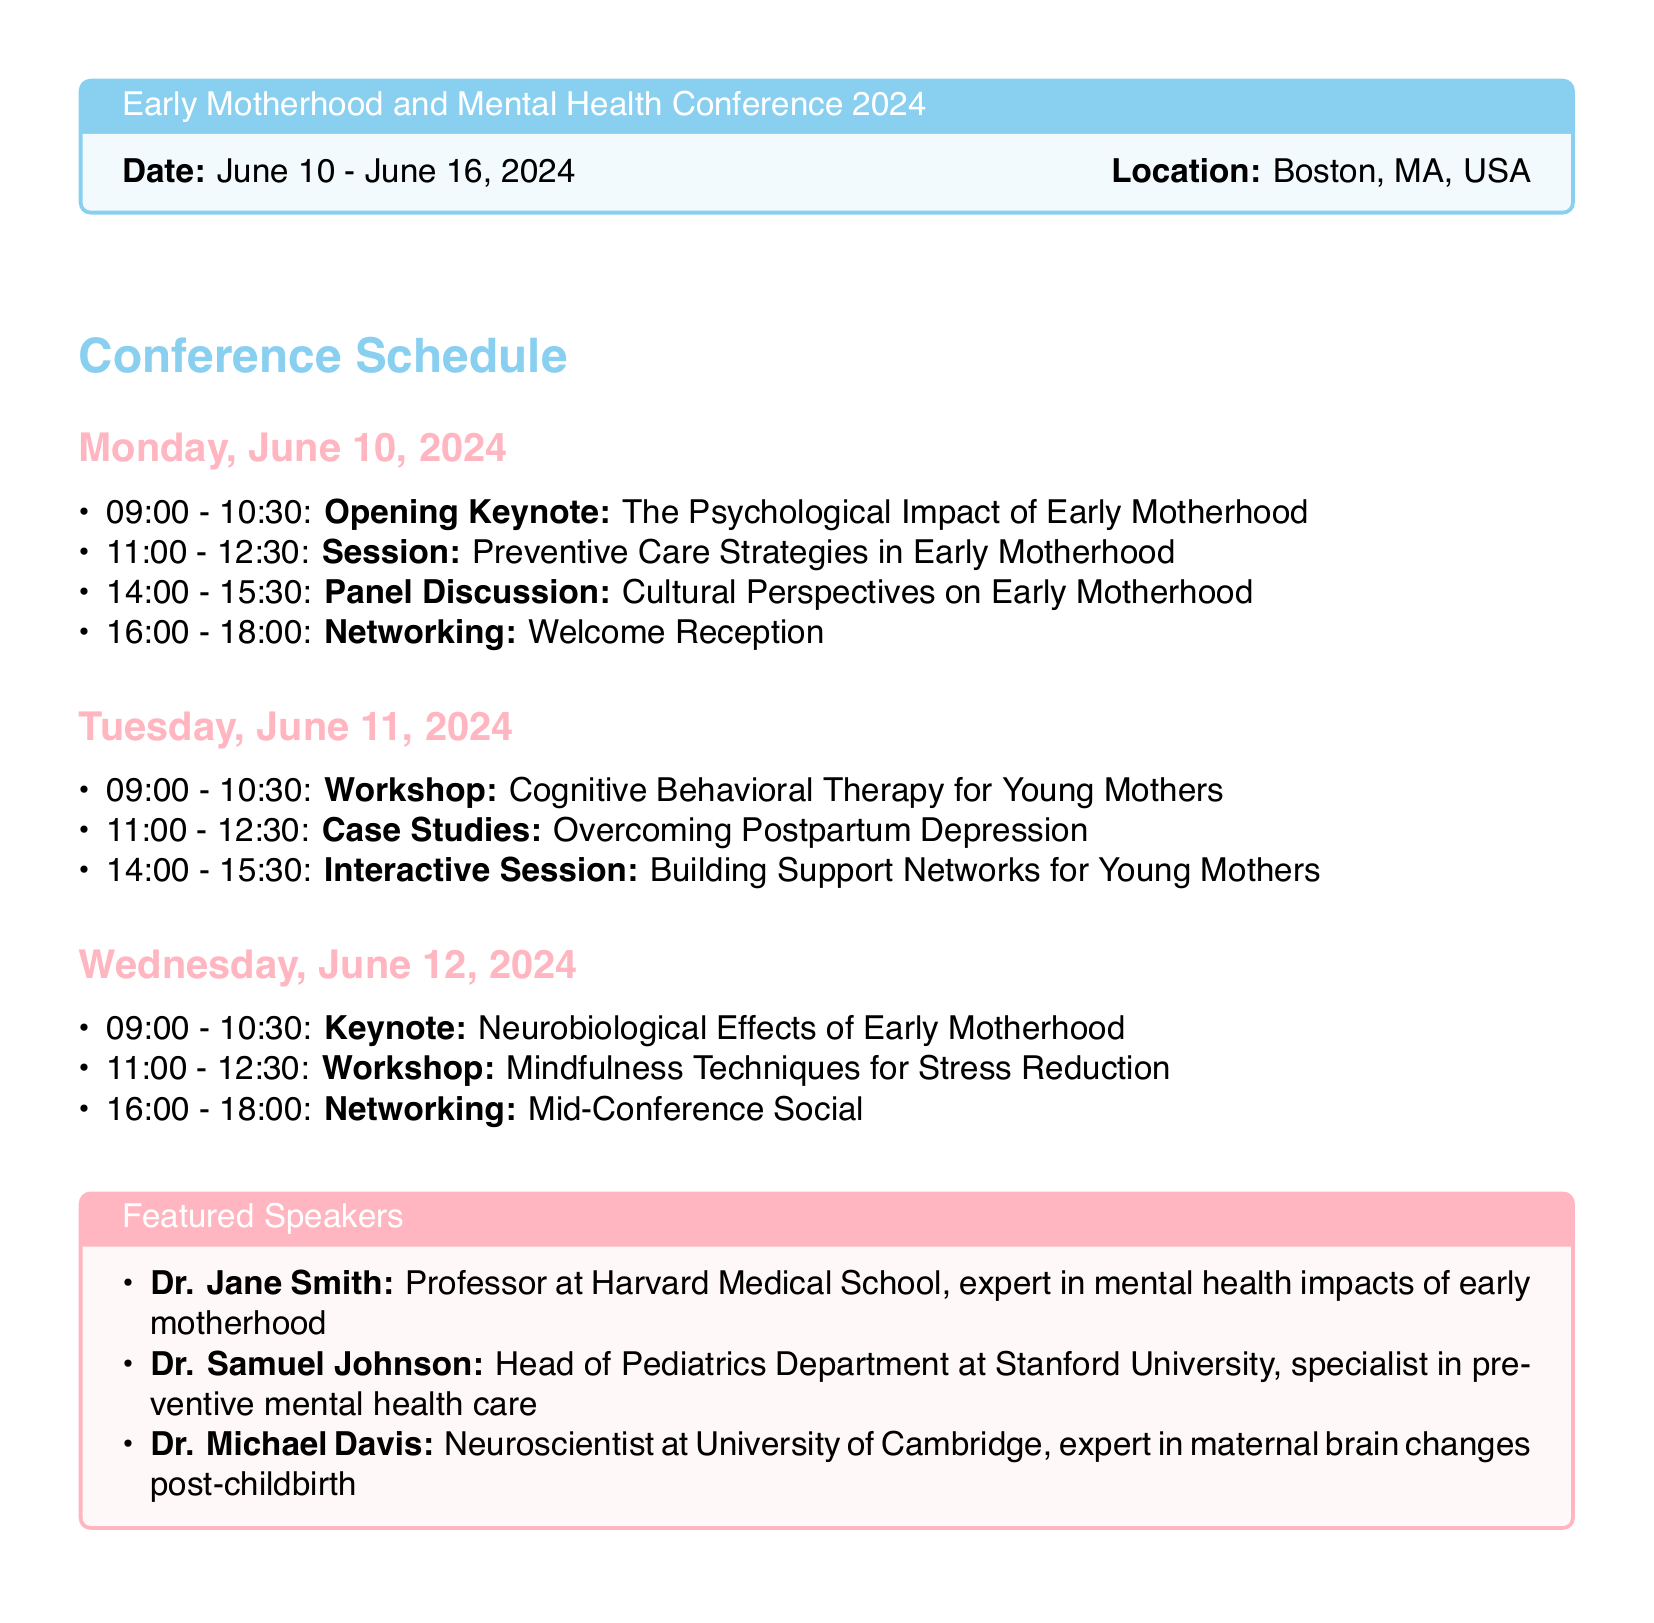What are the dates of the conference? The conference is held from June 10 to June 16, 2024.
Answer: June 10 - June 16, 2024 Who is the keynote speaker on June 12, 2024? The keynote session on June 12 is titled "Neurobiological Effects of Early Motherhood."
Answer: Neurobiological Effects of Early Motherhood What time does the welcome reception start on June 10? The welcome reception on June 10 starts at 16:00.
Answer: 16:00 Which speaker is an expert in maternal brain changes post-childbirth? The speaker specializing in maternal brain changes is Dr. Michael Davis.
Answer: Dr. Michael Davis How many networking events are scheduled during the conference? There are two networking events mentioned in the itinerary.
Answer: Two What type of session is planned on June 11 at 09:00? The session at that time is a workshop.
Answer: Workshop What is the focus of the workshop on June 11? The workshop is focused on Cognitive Behavioral Therapy for Young Mothers.
Answer: Cognitive Behavioral Therapy for Young Mothers Which university is Dr. Jane Smith affiliated with? Dr. Jane Smith is affiliated with Harvard Medical School.
Answer: Harvard Medical School What topic is covered in the panel discussion on June 10? The panel discussion covers Cultural Perspectives on Early Motherhood.
Answer: Cultural Perspectives on Early Motherhood 